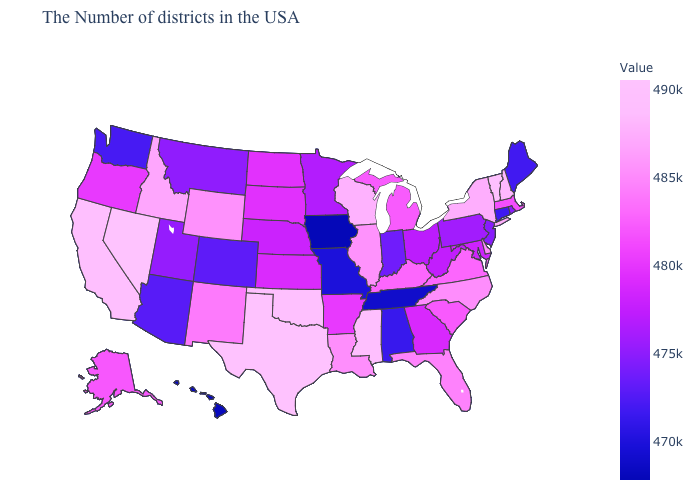Among the states that border California , which have the highest value?
Answer briefly. Nevada. Which states have the lowest value in the USA?
Give a very brief answer. Iowa. Does Tennessee have the lowest value in the South?
Keep it brief. Yes. 